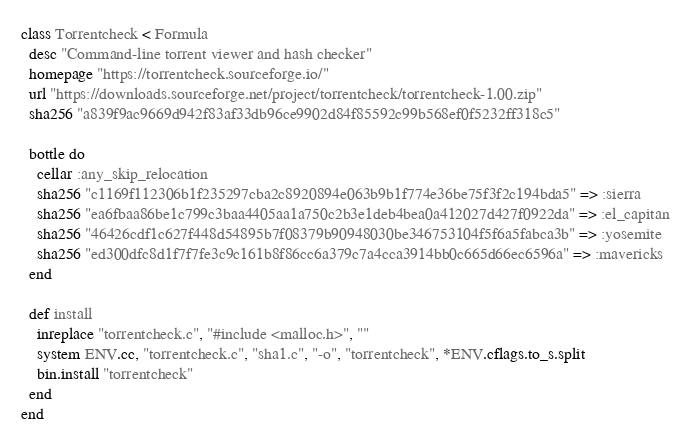Convert code to text. <code><loc_0><loc_0><loc_500><loc_500><_Ruby_>class Torrentcheck < Formula
  desc "Command-line torrent viewer and hash checker"
  homepage "https://torrentcheck.sourceforge.io/"
  url "https://downloads.sourceforge.net/project/torrentcheck/torrentcheck-1.00.zip"
  sha256 "a839f9ac9669d942f83af33db96ce9902d84f85592c99b568ef0f5232ff318c5"

  bottle do
    cellar :any_skip_relocation
    sha256 "c1169f112306b1f235297cba2c8920894e063b9b1f774e36be75f3f2c194bda5" => :sierra
    sha256 "ea6fbaa86be1c799c3baa4405aa1a750c2b3e1deb4bea0a412027d427f0922da" => :el_capitan
    sha256 "46426cdf1c627f448d54895b7f08379b90948030be346753104f5f6a5fabca3b" => :yosemite
    sha256 "ed300dfc8d1f7f7fe3c9c161b8f86cc6a379c7a4cca3914bb0c665d66ec6596a" => :mavericks
  end

  def install
    inreplace "torrentcheck.c", "#include <malloc.h>", ""
    system ENV.cc, "torrentcheck.c", "sha1.c", "-o", "torrentcheck", *ENV.cflags.to_s.split
    bin.install "torrentcheck"
  end
end
</code> 